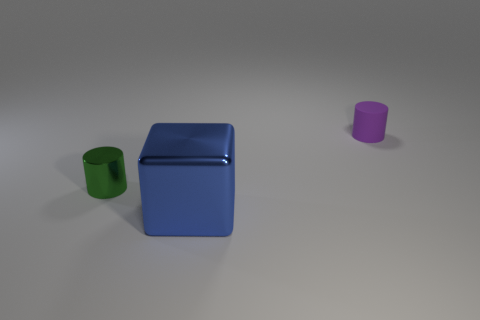Do the rubber object and the small metallic thing have the same color?
Give a very brief answer. No. What color is the tiny metal object that is the same shape as the tiny rubber thing?
Your answer should be compact. Green. How many cylinders have the same color as the block?
Make the answer very short. 0. There is a shiny thing that is right of the tiny green object that is in front of the tiny cylinder that is on the right side of the tiny green metallic cylinder; what color is it?
Keep it short and to the point. Blue. Do the green thing and the block have the same material?
Make the answer very short. Yes. Do the blue object and the small green object have the same shape?
Provide a succinct answer. No. Are there the same number of blue metallic blocks behind the metallic cylinder and small green shiny objects that are right of the purple cylinder?
Give a very brief answer. Yes. There is a small object that is made of the same material as the big object; what is its color?
Make the answer very short. Green. What number of other large blocks have the same material as the blue block?
Provide a short and direct response. 0. There is a tiny cylinder in front of the tiny purple matte object; does it have the same color as the tiny matte thing?
Give a very brief answer. No. 